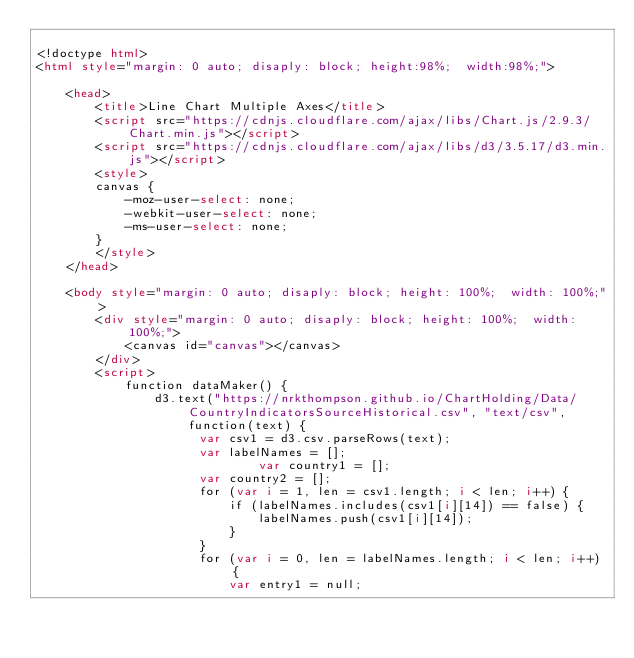<code> <loc_0><loc_0><loc_500><loc_500><_HTML_>
<!doctype html>
<html style="margin: 0 auto; disaply: block; height:98%;  width:98%;">

	<head>
		<title>Line Chart Multiple Axes</title>
		<script src="https://cdnjs.cloudflare.com/ajax/libs/Chart.js/2.9.3/Chart.min.js"></script>
		<script src="https://cdnjs.cloudflare.com/ajax/libs/d3/3.5.17/d3.min.js"></script>
		<style>
		canvas {
			-moz-user-select: none;
			-webkit-user-select: none;
			-ms-user-select: none;
		}
		</style>
	</head>

	<body style="margin: 0 auto; disaply: block; height: 100%;  width: 100%;">
		<div style="margin: 0 auto; disaply: block; height: 100%;  width: 100%;">
			<canvas id="canvas"></canvas>
		</div>
		<script>
			function dataMaker() {
				d3.text("https://nrkthompson.github.io/ChartHolding/Data/CountryIndicatorsSourceHistorical.csv", "text/csv", function(text) {
					  var csv1 = d3.csv.parseRows(text);
					  var labelNames = [];
            				  var country1 = [];
					  var country2 = [];
					  for (var i = 1, len = csv1.length; i < len; i++) {
						  if (labelNames.includes(csv1[i][14]) == false) {
							  labelNames.push(csv1[i][14]);
						  }
					  }
					  for (var i = 0, len = labelNames.length; i < len; i++) {
						  var entry1 = null;</code> 